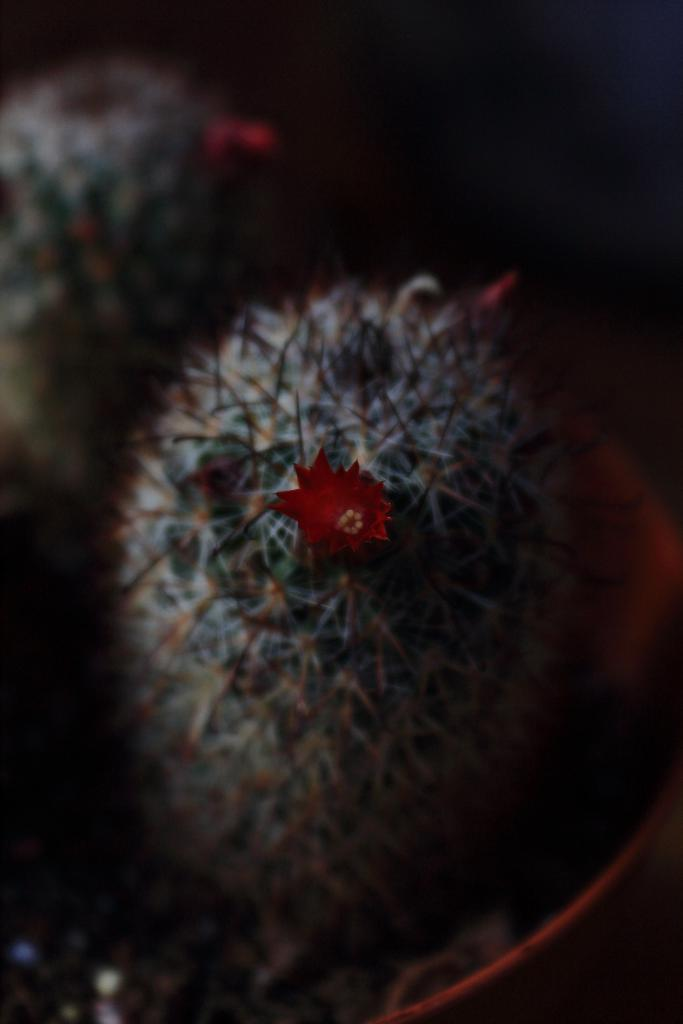What is the main subject of the image? There is a plant in the center of the image. What can be observed about the plant? The plant has flowers. What type of glove can be seen holding a pear in the image? There is no glove or pear present in the image; it only features a plant with flowers. 